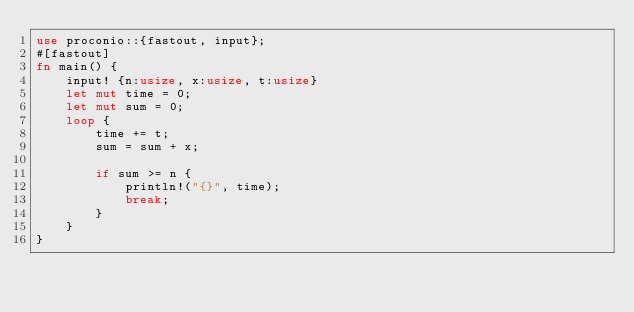Convert code to text. <code><loc_0><loc_0><loc_500><loc_500><_Rust_>use proconio::{fastout, input};
#[fastout]
fn main() {
    input! {n:usize, x:usize, t:usize}
    let mut time = 0;
    let mut sum = 0;
    loop {
        time += t;
        sum = sum + x;

        if sum >= n {
            println!("{}", time);
            break;
        }
    }
}
</code> 